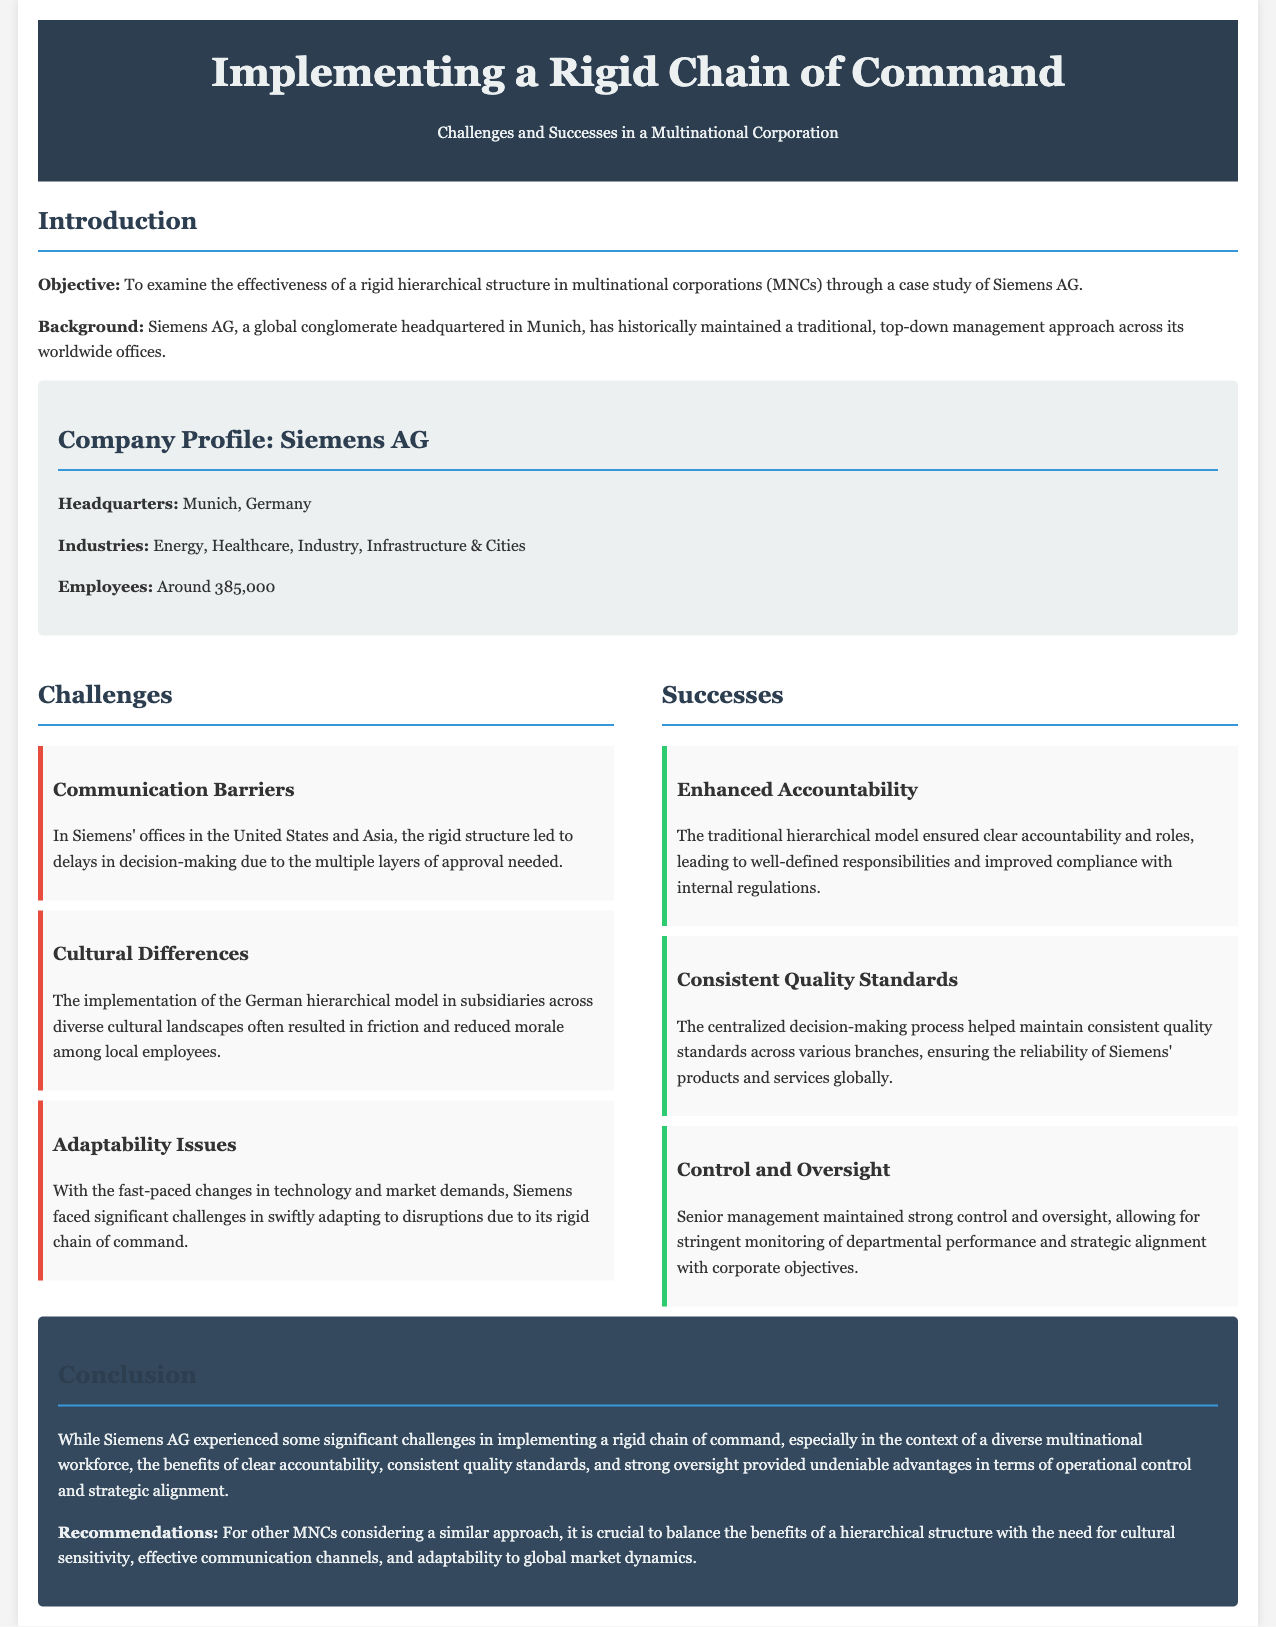What is the headquarters of Siemens AG? The location of Siemens AG's headquarters is mentioned in the company profile section.
Answer: Munich, Germany How many employees does Siemens AG have? The document states the number of employees in the company profile section.
Answer: Around 385,000 What is one major challenge faced by Siemens in implementing a rigid chain of command? The specific challenges are listed in the challenges section, one of which is communication barriers.
Answer: Communication Barriers What success is cited regarding accountability in the report? The document lists the successes, including enhanced accountability from the hierarchical model.
Answer: Enhanced Accountability How did Siemens ensure consistent quality across its branches? The reason for maintaining consistent quality standards is mentioned as part of the successes of the rigid structure.
Answer: Centralized decision-making process What did Siemens experience regarding cultural differences? This is described in the challenges section, highlighting issues stemming from the implementation of the German model.
Answer: Friction and reduced morale What are the two main industries Siemens AG operates in? The industries Siemens operates in are mentioned in the company profile section.
Answer: Energy, Healthcare What is one recommendation for other MNCs considering a hierarchical structure? The conclusion section offers recommendations, which include the importance of cultural sensitivity.
Answer: Cultural sensitivity What is the overall conclusion regarding the implementation of a rigid chain of command? The document summarizes that despite challenges, there were undeniable advantages to operational control.
Answer: Undeniable advantages in operational control 